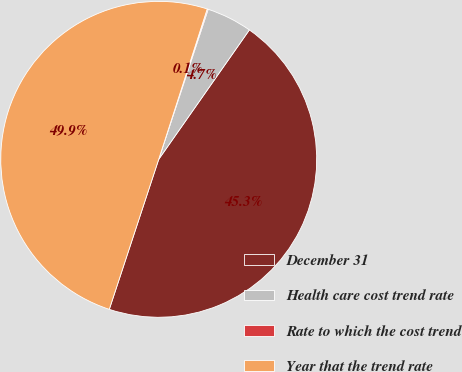Convert chart. <chart><loc_0><loc_0><loc_500><loc_500><pie_chart><fcel>December 31<fcel>Health care cost trend rate<fcel>Rate to which the cost trend<fcel>Year that the trend rate<nl><fcel>45.34%<fcel>4.66%<fcel>0.1%<fcel>49.9%<nl></chart> 